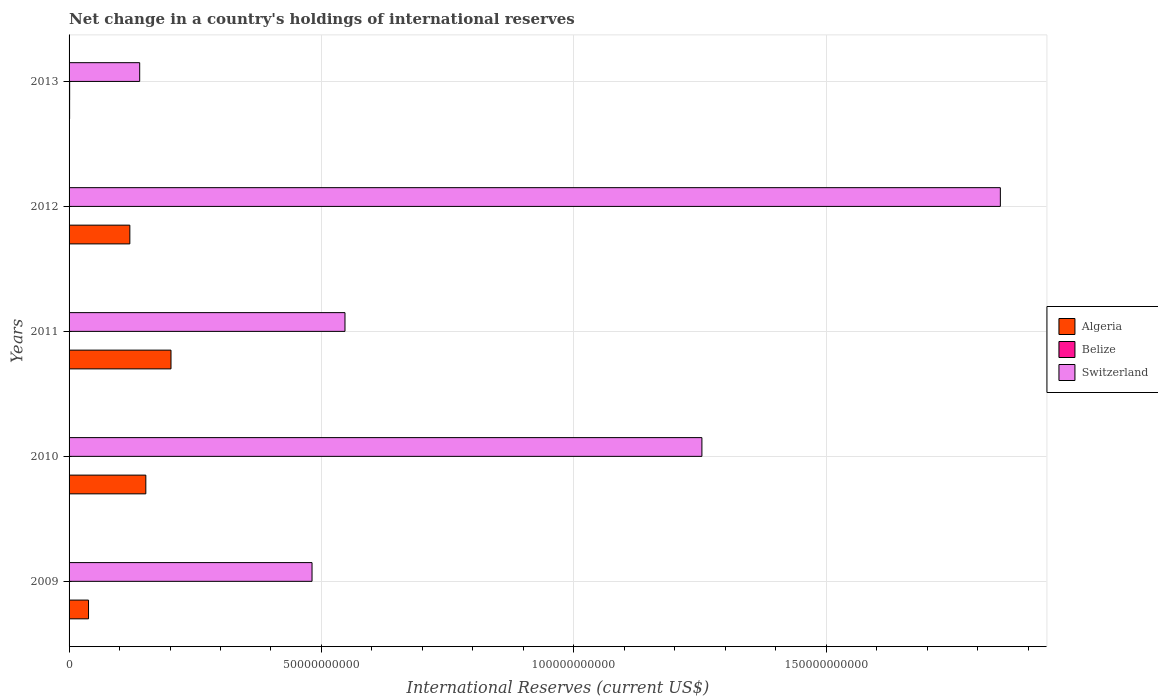How many bars are there on the 5th tick from the bottom?
Your response must be concise. 3. What is the international reserves in Algeria in 2010?
Provide a short and direct response. 1.52e+1. Across all years, what is the maximum international reserves in Switzerland?
Your answer should be very brief. 1.85e+11. Across all years, what is the minimum international reserves in Belize?
Keep it short and to the point. 4.99e+06. What is the total international reserves in Belize in the graph?
Your answer should be compact. 2.36e+08. What is the difference between the international reserves in Switzerland in 2012 and that in 2013?
Offer a very short reply. 1.71e+11. What is the difference between the international reserves in Switzerland in 2010 and the international reserves in Algeria in 2009?
Make the answer very short. 1.22e+11. What is the average international reserves in Belize per year?
Your answer should be compact. 4.72e+07. In the year 2011, what is the difference between the international reserves in Algeria and international reserves in Belize?
Provide a short and direct response. 2.02e+1. In how many years, is the international reserves in Switzerland greater than 170000000000 US$?
Your answer should be compact. 1. What is the ratio of the international reserves in Switzerland in 2009 to that in 2013?
Ensure brevity in your answer.  3.44. Is the international reserves in Switzerland in 2011 less than that in 2012?
Make the answer very short. Yes. What is the difference between the highest and the second highest international reserves in Algeria?
Provide a short and direct response. 4.99e+09. What is the difference between the highest and the lowest international reserves in Switzerland?
Your answer should be very brief. 1.71e+11. What does the 3rd bar from the top in 2009 represents?
Give a very brief answer. Algeria. What does the 3rd bar from the bottom in 2012 represents?
Offer a very short reply. Switzerland. How many bars are there?
Keep it short and to the point. 15. Are all the bars in the graph horizontal?
Keep it short and to the point. Yes. How many years are there in the graph?
Your answer should be compact. 5. What is the difference between two consecutive major ticks on the X-axis?
Your response must be concise. 5.00e+1. How many legend labels are there?
Offer a terse response. 3. What is the title of the graph?
Your response must be concise. Net change in a country's holdings of international reserves. Does "Luxembourg" appear as one of the legend labels in the graph?
Offer a very short reply. No. What is the label or title of the X-axis?
Ensure brevity in your answer.  International Reserves (current US$). What is the label or title of the Y-axis?
Your answer should be very brief. Years. What is the International Reserves (current US$) in Algeria in 2009?
Offer a terse response. 3.86e+09. What is the International Reserves (current US$) of Belize in 2009?
Your answer should be very brief. 4.00e+07. What is the International Reserves (current US$) in Switzerland in 2009?
Offer a terse response. 4.81e+1. What is the International Reserves (current US$) in Algeria in 2010?
Make the answer very short. 1.52e+1. What is the International Reserves (current US$) of Belize in 2010?
Give a very brief answer. 4.99e+06. What is the International Reserves (current US$) in Switzerland in 2010?
Make the answer very short. 1.25e+11. What is the International Reserves (current US$) in Algeria in 2011?
Provide a short and direct response. 2.02e+1. What is the International Reserves (current US$) in Belize in 2011?
Provide a succinct answer. 1.82e+07. What is the International Reserves (current US$) of Switzerland in 2011?
Your answer should be compact. 5.47e+1. What is the International Reserves (current US$) in Algeria in 2012?
Your response must be concise. 1.20e+1. What is the International Reserves (current US$) in Belize in 2012?
Provide a short and direct response. 5.55e+07. What is the International Reserves (current US$) of Switzerland in 2012?
Make the answer very short. 1.85e+11. What is the International Reserves (current US$) in Algeria in 2013?
Your answer should be compact. 1.07e+08. What is the International Reserves (current US$) of Belize in 2013?
Provide a succinct answer. 1.17e+08. What is the International Reserves (current US$) in Switzerland in 2013?
Keep it short and to the point. 1.40e+1. Across all years, what is the maximum International Reserves (current US$) of Algeria?
Provide a succinct answer. 2.02e+1. Across all years, what is the maximum International Reserves (current US$) in Belize?
Your response must be concise. 1.17e+08. Across all years, what is the maximum International Reserves (current US$) in Switzerland?
Provide a short and direct response. 1.85e+11. Across all years, what is the minimum International Reserves (current US$) in Algeria?
Keep it short and to the point. 1.07e+08. Across all years, what is the minimum International Reserves (current US$) in Belize?
Provide a short and direct response. 4.99e+06. Across all years, what is the minimum International Reserves (current US$) in Switzerland?
Offer a terse response. 1.40e+1. What is the total International Reserves (current US$) in Algeria in the graph?
Provide a succinct answer. 5.14e+1. What is the total International Reserves (current US$) of Belize in the graph?
Your answer should be very brief. 2.36e+08. What is the total International Reserves (current US$) of Switzerland in the graph?
Your answer should be very brief. 4.27e+11. What is the difference between the International Reserves (current US$) of Algeria in 2009 and that in 2010?
Your answer should be compact. -1.14e+1. What is the difference between the International Reserves (current US$) in Belize in 2009 and that in 2010?
Offer a terse response. 3.50e+07. What is the difference between the International Reserves (current US$) of Switzerland in 2009 and that in 2010?
Make the answer very short. -7.72e+1. What is the difference between the International Reserves (current US$) in Algeria in 2009 and that in 2011?
Provide a short and direct response. -1.63e+1. What is the difference between the International Reserves (current US$) in Belize in 2009 and that in 2011?
Offer a terse response. 2.18e+07. What is the difference between the International Reserves (current US$) in Switzerland in 2009 and that in 2011?
Provide a short and direct response. -6.53e+09. What is the difference between the International Reserves (current US$) of Algeria in 2009 and that in 2012?
Provide a short and direct response. -8.18e+09. What is the difference between the International Reserves (current US$) of Belize in 2009 and that in 2012?
Provide a short and direct response. -1.54e+07. What is the difference between the International Reserves (current US$) in Switzerland in 2009 and that in 2012?
Your answer should be compact. -1.36e+11. What is the difference between the International Reserves (current US$) in Algeria in 2009 and that in 2013?
Your answer should be compact. 3.75e+09. What is the difference between the International Reserves (current US$) of Belize in 2009 and that in 2013?
Offer a very short reply. -7.73e+07. What is the difference between the International Reserves (current US$) of Switzerland in 2009 and that in 2013?
Provide a succinct answer. 3.41e+1. What is the difference between the International Reserves (current US$) in Algeria in 2010 and that in 2011?
Provide a succinct answer. -4.99e+09. What is the difference between the International Reserves (current US$) of Belize in 2010 and that in 2011?
Make the answer very short. -1.32e+07. What is the difference between the International Reserves (current US$) of Switzerland in 2010 and that in 2011?
Ensure brevity in your answer.  7.07e+1. What is the difference between the International Reserves (current US$) in Algeria in 2010 and that in 2012?
Provide a short and direct response. 3.17e+09. What is the difference between the International Reserves (current US$) in Belize in 2010 and that in 2012?
Your response must be concise. -5.05e+07. What is the difference between the International Reserves (current US$) in Switzerland in 2010 and that in 2012?
Keep it short and to the point. -5.91e+1. What is the difference between the International Reserves (current US$) in Algeria in 2010 and that in 2013?
Your answer should be compact. 1.51e+1. What is the difference between the International Reserves (current US$) of Belize in 2010 and that in 2013?
Provide a short and direct response. -1.12e+08. What is the difference between the International Reserves (current US$) of Switzerland in 2010 and that in 2013?
Give a very brief answer. 1.11e+11. What is the difference between the International Reserves (current US$) in Algeria in 2011 and that in 2012?
Your response must be concise. 8.15e+09. What is the difference between the International Reserves (current US$) in Belize in 2011 and that in 2012?
Your answer should be compact. -3.72e+07. What is the difference between the International Reserves (current US$) in Switzerland in 2011 and that in 2012?
Ensure brevity in your answer.  -1.30e+11. What is the difference between the International Reserves (current US$) of Algeria in 2011 and that in 2013?
Your response must be concise. 2.01e+1. What is the difference between the International Reserves (current US$) in Belize in 2011 and that in 2013?
Your answer should be very brief. -9.91e+07. What is the difference between the International Reserves (current US$) of Switzerland in 2011 and that in 2013?
Give a very brief answer. 4.07e+1. What is the difference between the International Reserves (current US$) of Algeria in 2012 and that in 2013?
Provide a succinct answer. 1.19e+1. What is the difference between the International Reserves (current US$) of Belize in 2012 and that in 2013?
Offer a terse response. -6.19e+07. What is the difference between the International Reserves (current US$) in Switzerland in 2012 and that in 2013?
Offer a very short reply. 1.71e+11. What is the difference between the International Reserves (current US$) in Algeria in 2009 and the International Reserves (current US$) in Belize in 2010?
Keep it short and to the point. 3.85e+09. What is the difference between the International Reserves (current US$) of Algeria in 2009 and the International Reserves (current US$) of Switzerland in 2010?
Offer a very short reply. -1.22e+11. What is the difference between the International Reserves (current US$) of Belize in 2009 and the International Reserves (current US$) of Switzerland in 2010?
Provide a succinct answer. -1.25e+11. What is the difference between the International Reserves (current US$) of Algeria in 2009 and the International Reserves (current US$) of Belize in 2011?
Your response must be concise. 3.84e+09. What is the difference between the International Reserves (current US$) in Algeria in 2009 and the International Reserves (current US$) in Switzerland in 2011?
Offer a very short reply. -5.08e+1. What is the difference between the International Reserves (current US$) of Belize in 2009 and the International Reserves (current US$) of Switzerland in 2011?
Keep it short and to the point. -5.46e+1. What is the difference between the International Reserves (current US$) in Algeria in 2009 and the International Reserves (current US$) in Belize in 2012?
Your answer should be compact. 3.80e+09. What is the difference between the International Reserves (current US$) of Algeria in 2009 and the International Reserves (current US$) of Switzerland in 2012?
Your answer should be very brief. -1.81e+11. What is the difference between the International Reserves (current US$) of Belize in 2009 and the International Reserves (current US$) of Switzerland in 2012?
Give a very brief answer. -1.84e+11. What is the difference between the International Reserves (current US$) in Algeria in 2009 and the International Reserves (current US$) in Belize in 2013?
Offer a very short reply. 3.74e+09. What is the difference between the International Reserves (current US$) of Algeria in 2009 and the International Reserves (current US$) of Switzerland in 2013?
Offer a terse response. -1.01e+1. What is the difference between the International Reserves (current US$) in Belize in 2009 and the International Reserves (current US$) in Switzerland in 2013?
Offer a very short reply. -1.40e+1. What is the difference between the International Reserves (current US$) in Algeria in 2010 and the International Reserves (current US$) in Belize in 2011?
Ensure brevity in your answer.  1.52e+1. What is the difference between the International Reserves (current US$) of Algeria in 2010 and the International Reserves (current US$) of Switzerland in 2011?
Offer a terse response. -3.95e+1. What is the difference between the International Reserves (current US$) in Belize in 2010 and the International Reserves (current US$) in Switzerland in 2011?
Your answer should be compact. -5.47e+1. What is the difference between the International Reserves (current US$) in Algeria in 2010 and the International Reserves (current US$) in Belize in 2012?
Provide a succinct answer. 1.52e+1. What is the difference between the International Reserves (current US$) of Algeria in 2010 and the International Reserves (current US$) of Switzerland in 2012?
Give a very brief answer. -1.69e+11. What is the difference between the International Reserves (current US$) of Belize in 2010 and the International Reserves (current US$) of Switzerland in 2012?
Your response must be concise. -1.85e+11. What is the difference between the International Reserves (current US$) in Algeria in 2010 and the International Reserves (current US$) in Belize in 2013?
Your answer should be very brief. 1.51e+1. What is the difference between the International Reserves (current US$) of Algeria in 2010 and the International Reserves (current US$) of Switzerland in 2013?
Offer a very short reply. 1.22e+09. What is the difference between the International Reserves (current US$) of Belize in 2010 and the International Reserves (current US$) of Switzerland in 2013?
Your answer should be very brief. -1.40e+1. What is the difference between the International Reserves (current US$) in Algeria in 2011 and the International Reserves (current US$) in Belize in 2012?
Your answer should be very brief. 2.01e+1. What is the difference between the International Reserves (current US$) of Algeria in 2011 and the International Reserves (current US$) of Switzerland in 2012?
Offer a very short reply. -1.64e+11. What is the difference between the International Reserves (current US$) of Belize in 2011 and the International Reserves (current US$) of Switzerland in 2012?
Provide a succinct answer. -1.84e+11. What is the difference between the International Reserves (current US$) in Algeria in 2011 and the International Reserves (current US$) in Belize in 2013?
Ensure brevity in your answer.  2.01e+1. What is the difference between the International Reserves (current US$) of Algeria in 2011 and the International Reserves (current US$) of Switzerland in 2013?
Offer a terse response. 6.20e+09. What is the difference between the International Reserves (current US$) of Belize in 2011 and the International Reserves (current US$) of Switzerland in 2013?
Offer a terse response. -1.40e+1. What is the difference between the International Reserves (current US$) of Algeria in 2012 and the International Reserves (current US$) of Belize in 2013?
Provide a succinct answer. 1.19e+1. What is the difference between the International Reserves (current US$) of Algeria in 2012 and the International Reserves (current US$) of Switzerland in 2013?
Ensure brevity in your answer.  -1.95e+09. What is the difference between the International Reserves (current US$) in Belize in 2012 and the International Reserves (current US$) in Switzerland in 2013?
Offer a very short reply. -1.39e+1. What is the average International Reserves (current US$) of Algeria per year?
Keep it short and to the point. 1.03e+1. What is the average International Reserves (current US$) of Belize per year?
Offer a terse response. 4.72e+07. What is the average International Reserves (current US$) in Switzerland per year?
Make the answer very short. 8.53e+1. In the year 2009, what is the difference between the International Reserves (current US$) in Algeria and International Reserves (current US$) in Belize?
Your answer should be compact. 3.82e+09. In the year 2009, what is the difference between the International Reserves (current US$) in Algeria and International Reserves (current US$) in Switzerland?
Your answer should be very brief. -4.43e+1. In the year 2009, what is the difference between the International Reserves (current US$) of Belize and International Reserves (current US$) of Switzerland?
Offer a terse response. -4.81e+1. In the year 2010, what is the difference between the International Reserves (current US$) in Algeria and International Reserves (current US$) in Belize?
Your answer should be compact. 1.52e+1. In the year 2010, what is the difference between the International Reserves (current US$) in Algeria and International Reserves (current US$) in Switzerland?
Provide a succinct answer. -1.10e+11. In the year 2010, what is the difference between the International Reserves (current US$) in Belize and International Reserves (current US$) in Switzerland?
Your answer should be very brief. -1.25e+11. In the year 2011, what is the difference between the International Reserves (current US$) of Algeria and International Reserves (current US$) of Belize?
Give a very brief answer. 2.02e+1. In the year 2011, what is the difference between the International Reserves (current US$) of Algeria and International Reserves (current US$) of Switzerland?
Keep it short and to the point. -3.45e+1. In the year 2011, what is the difference between the International Reserves (current US$) in Belize and International Reserves (current US$) in Switzerland?
Make the answer very short. -5.46e+1. In the year 2012, what is the difference between the International Reserves (current US$) of Algeria and International Reserves (current US$) of Belize?
Offer a very short reply. 1.20e+1. In the year 2012, what is the difference between the International Reserves (current US$) in Algeria and International Reserves (current US$) in Switzerland?
Keep it short and to the point. -1.72e+11. In the year 2012, what is the difference between the International Reserves (current US$) in Belize and International Reserves (current US$) in Switzerland?
Make the answer very short. -1.84e+11. In the year 2013, what is the difference between the International Reserves (current US$) of Algeria and International Reserves (current US$) of Belize?
Make the answer very short. -1.00e+07. In the year 2013, what is the difference between the International Reserves (current US$) in Algeria and International Reserves (current US$) in Switzerland?
Provide a succinct answer. -1.39e+1. In the year 2013, what is the difference between the International Reserves (current US$) in Belize and International Reserves (current US$) in Switzerland?
Make the answer very short. -1.39e+1. What is the ratio of the International Reserves (current US$) of Algeria in 2009 to that in 2010?
Provide a short and direct response. 0.25. What is the ratio of the International Reserves (current US$) in Belize in 2009 to that in 2010?
Offer a very short reply. 8.02. What is the ratio of the International Reserves (current US$) of Switzerland in 2009 to that in 2010?
Your response must be concise. 0.38. What is the ratio of the International Reserves (current US$) in Algeria in 2009 to that in 2011?
Give a very brief answer. 0.19. What is the ratio of the International Reserves (current US$) in Belize in 2009 to that in 2011?
Make the answer very short. 2.2. What is the ratio of the International Reserves (current US$) of Switzerland in 2009 to that in 2011?
Offer a very short reply. 0.88. What is the ratio of the International Reserves (current US$) of Algeria in 2009 to that in 2012?
Ensure brevity in your answer.  0.32. What is the ratio of the International Reserves (current US$) in Belize in 2009 to that in 2012?
Ensure brevity in your answer.  0.72. What is the ratio of the International Reserves (current US$) of Switzerland in 2009 to that in 2012?
Ensure brevity in your answer.  0.26. What is the ratio of the International Reserves (current US$) in Algeria in 2009 to that in 2013?
Keep it short and to the point. 35.95. What is the ratio of the International Reserves (current US$) in Belize in 2009 to that in 2013?
Offer a terse response. 0.34. What is the ratio of the International Reserves (current US$) in Switzerland in 2009 to that in 2013?
Provide a succinct answer. 3.44. What is the ratio of the International Reserves (current US$) in Algeria in 2010 to that in 2011?
Provide a succinct answer. 0.75. What is the ratio of the International Reserves (current US$) of Belize in 2010 to that in 2011?
Provide a short and direct response. 0.27. What is the ratio of the International Reserves (current US$) of Switzerland in 2010 to that in 2011?
Your response must be concise. 2.29. What is the ratio of the International Reserves (current US$) in Algeria in 2010 to that in 2012?
Your answer should be compact. 1.26. What is the ratio of the International Reserves (current US$) of Belize in 2010 to that in 2012?
Offer a very short reply. 0.09. What is the ratio of the International Reserves (current US$) in Switzerland in 2010 to that in 2012?
Make the answer very short. 0.68. What is the ratio of the International Reserves (current US$) of Algeria in 2010 to that in 2013?
Your answer should be very brief. 141.76. What is the ratio of the International Reserves (current US$) of Belize in 2010 to that in 2013?
Your answer should be compact. 0.04. What is the ratio of the International Reserves (current US$) in Switzerland in 2010 to that in 2013?
Keep it short and to the point. 8.96. What is the ratio of the International Reserves (current US$) in Algeria in 2011 to that in 2012?
Your answer should be very brief. 1.68. What is the ratio of the International Reserves (current US$) in Belize in 2011 to that in 2012?
Offer a terse response. 0.33. What is the ratio of the International Reserves (current US$) of Switzerland in 2011 to that in 2012?
Offer a very short reply. 0.3. What is the ratio of the International Reserves (current US$) of Algeria in 2011 to that in 2013?
Your response must be concise. 188.24. What is the ratio of the International Reserves (current US$) of Belize in 2011 to that in 2013?
Your answer should be compact. 0.16. What is the ratio of the International Reserves (current US$) in Switzerland in 2011 to that in 2013?
Your response must be concise. 3.91. What is the ratio of the International Reserves (current US$) in Algeria in 2012 to that in 2013?
Offer a terse response. 112.23. What is the ratio of the International Reserves (current US$) in Belize in 2012 to that in 2013?
Offer a very short reply. 0.47. What is the ratio of the International Reserves (current US$) of Switzerland in 2012 to that in 2013?
Your answer should be compact. 13.19. What is the difference between the highest and the second highest International Reserves (current US$) in Algeria?
Your answer should be compact. 4.99e+09. What is the difference between the highest and the second highest International Reserves (current US$) of Belize?
Offer a terse response. 6.19e+07. What is the difference between the highest and the second highest International Reserves (current US$) of Switzerland?
Your response must be concise. 5.91e+1. What is the difference between the highest and the lowest International Reserves (current US$) in Algeria?
Ensure brevity in your answer.  2.01e+1. What is the difference between the highest and the lowest International Reserves (current US$) of Belize?
Keep it short and to the point. 1.12e+08. What is the difference between the highest and the lowest International Reserves (current US$) in Switzerland?
Offer a terse response. 1.71e+11. 